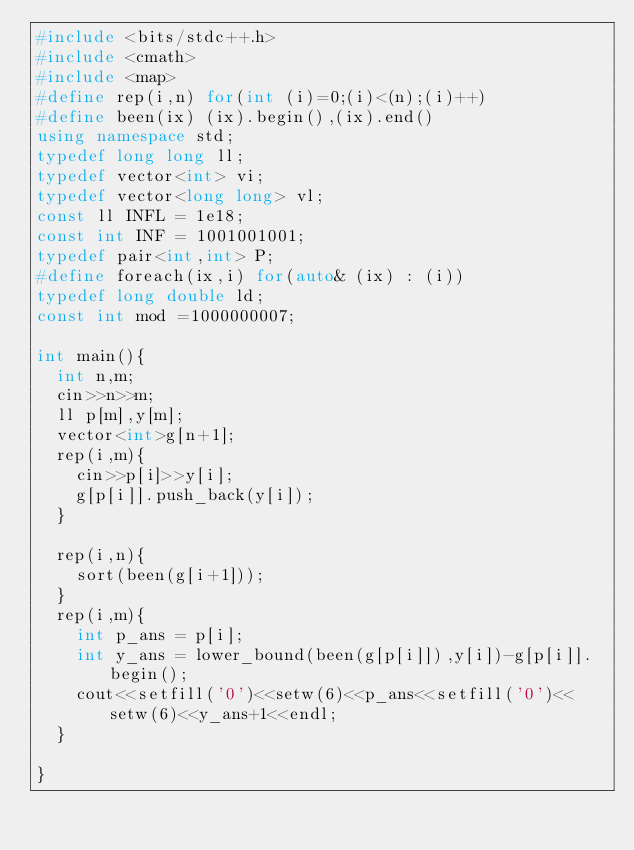<code> <loc_0><loc_0><loc_500><loc_500><_C++_>#include <bits/stdc++.h>
#include <cmath>
#include <map>
#define rep(i,n) for(int (i)=0;(i)<(n);(i)++)
#define been(ix) (ix).begin(),(ix).end()
using namespace std;
typedef long long ll; 
typedef vector<int> vi;
typedef vector<long long> vl;
const ll INFL = 1e18;
const int INF = 1001001001; 
typedef pair<int,int> P;
#define foreach(ix,i) for(auto& (ix) : (i))
typedef long double ld;
const int mod =1000000007;

int main(){
  int n,m;
  cin>>n>>m;
  ll p[m],y[m];
  vector<int>g[n+1];
  rep(i,m){
    cin>>p[i]>>y[i];
    g[p[i]].push_back(y[i]);
  }
  
  rep(i,n){
    sort(been(g[i+1]));
  }
  rep(i,m){
    int p_ans = p[i];
    int y_ans = lower_bound(been(g[p[i]]),y[i])-g[p[i]].begin();
    cout<<setfill('0')<<setw(6)<<p_ans<<setfill('0')<<setw(6)<<y_ans+1<<endl;
  }

}</code> 